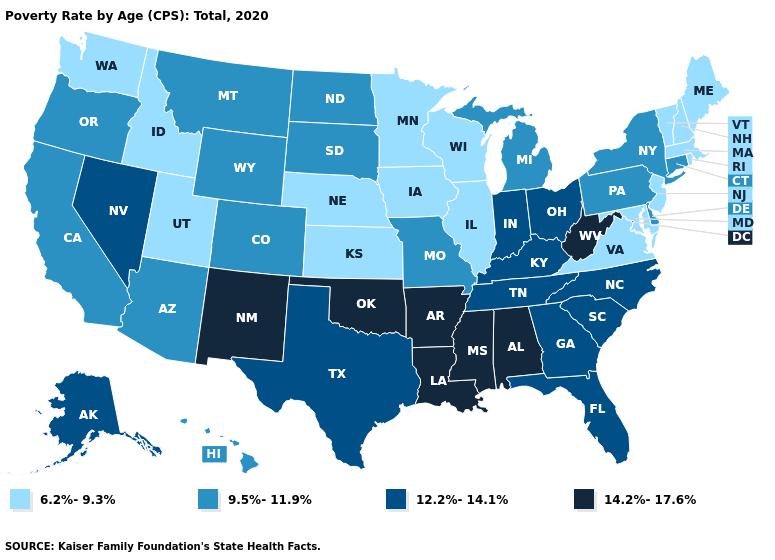Does South Dakota have a lower value than Alaska?
Answer briefly. Yes. Among the states that border Kentucky , which have the lowest value?
Concise answer only. Illinois, Virginia. Does North Carolina have the highest value in the USA?
Answer briefly. No. Which states have the lowest value in the West?
Quick response, please. Idaho, Utah, Washington. What is the lowest value in the USA?
Short answer required. 6.2%-9.3%. What is the value of Connecticut?
Keep it brief. 9.5%-11.9%. What is the value of Alabama?
Concise answer only. 14.2%-17.6%. Among the states that border Wisconsin , which have the lowest value?
Write a very short answer. Illinois, Iowa, Minnesota. Does Hawaii have a higher value than North Dakota?
Give a very brief answer. No. What is the value of North Carolina?
Answer briefly. 12.2%-14.1%. Does Indiana have a higher value than Louisiana?
Give a very brief answer. No. What is the highest value in the Northeast ?
Give a very brief answer. 9.5%-11.9%. Is the legend a continuous bar?
Keep it brief. No. What is the value of Tennessee?
Answer briefly. 12.2%-14.1%. What is the highest value in the USA?
Answer briefly. 14.2%-17.6%. 